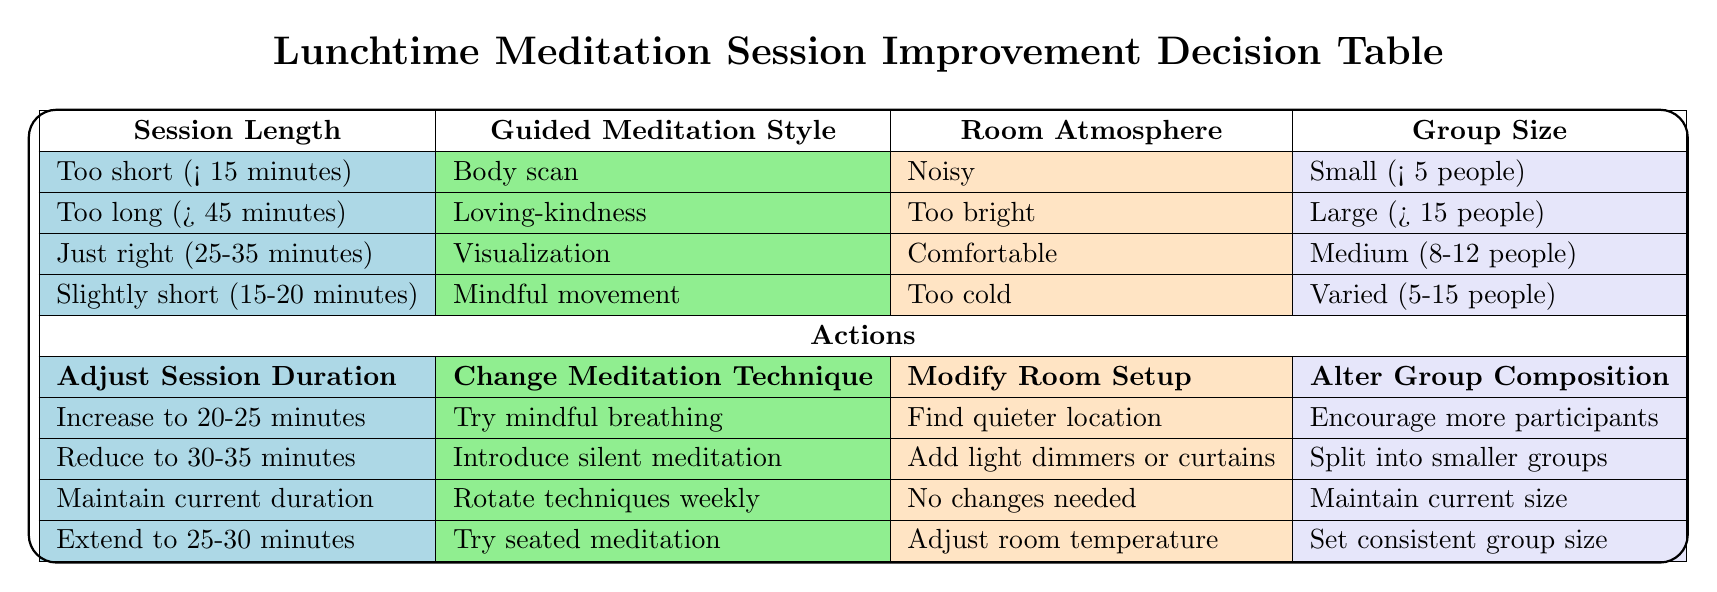What is the recommended duration adjustment for a session that is too short (less than 15 minutes)? The table shows that for a session labeled as "Too short (< 15 minutes)", the action is to "Increase to 20-25 minutes".
Answer: Increase to 20-25 minutes What change is suggested for the guided meditation style if the session is too long (more than 45 minutes)? According to the table, when the session is "Too long (> 45 minutes)", the suggested change is to "Introduce silent meditation".
Answer: Introduce silent meditation Is it true that the atmosphere for a comfortable session is classified as "Too cold"? Referring to the table, the session atmosphere labeled as "Comfortable" is listed under “Just right (25-35 minutes)”, not "Too cold". Therefore, the statement is false.
Answer: No What should be done regarding the room setup in a session characterized as slightly short (15-20 minutes)? The table indicates that when a session is described as "Slightly short (15-20 minutes)", the recommended action for the room setup is to "Adjust room temperature".
Answer: Adjust room temperature What is the group composition action for a session length that is just right (25-35 minutes)? The table specifies that for the "Just right (25-35 minutes)" duration, the suggested action for group composition is to "Maintain current size."
Answer: Maintain current size What modifications should be made to the room atmosphere if the session is described as too bright? For a session identified as "Too bright", the action listed in the table is to "Add light dimmers or curtains" under the recommendations for room setup.
Answer: Add light dimmers or curtains If the group size is too large (more than 15 people), what should be done? According to the table, for a session with a "Large (> 15 people)" group size, the action to take is to "Split into smaller groups."
Answer: Split into smaller groups In total, how many actions need to be taken if a session is described as too short, too bright, and has a small group size? Each issue refers to one specific action: for "Too short", the action is to "Increase to 20-25 minutes"; for "Too bright", the action is to "Add light dimmers or curtains"; and for "Small (< 5 people)", the recommendation is to "Encourage more participants." Therefore, the total number of actions needed is three.
Answer: Three actions 